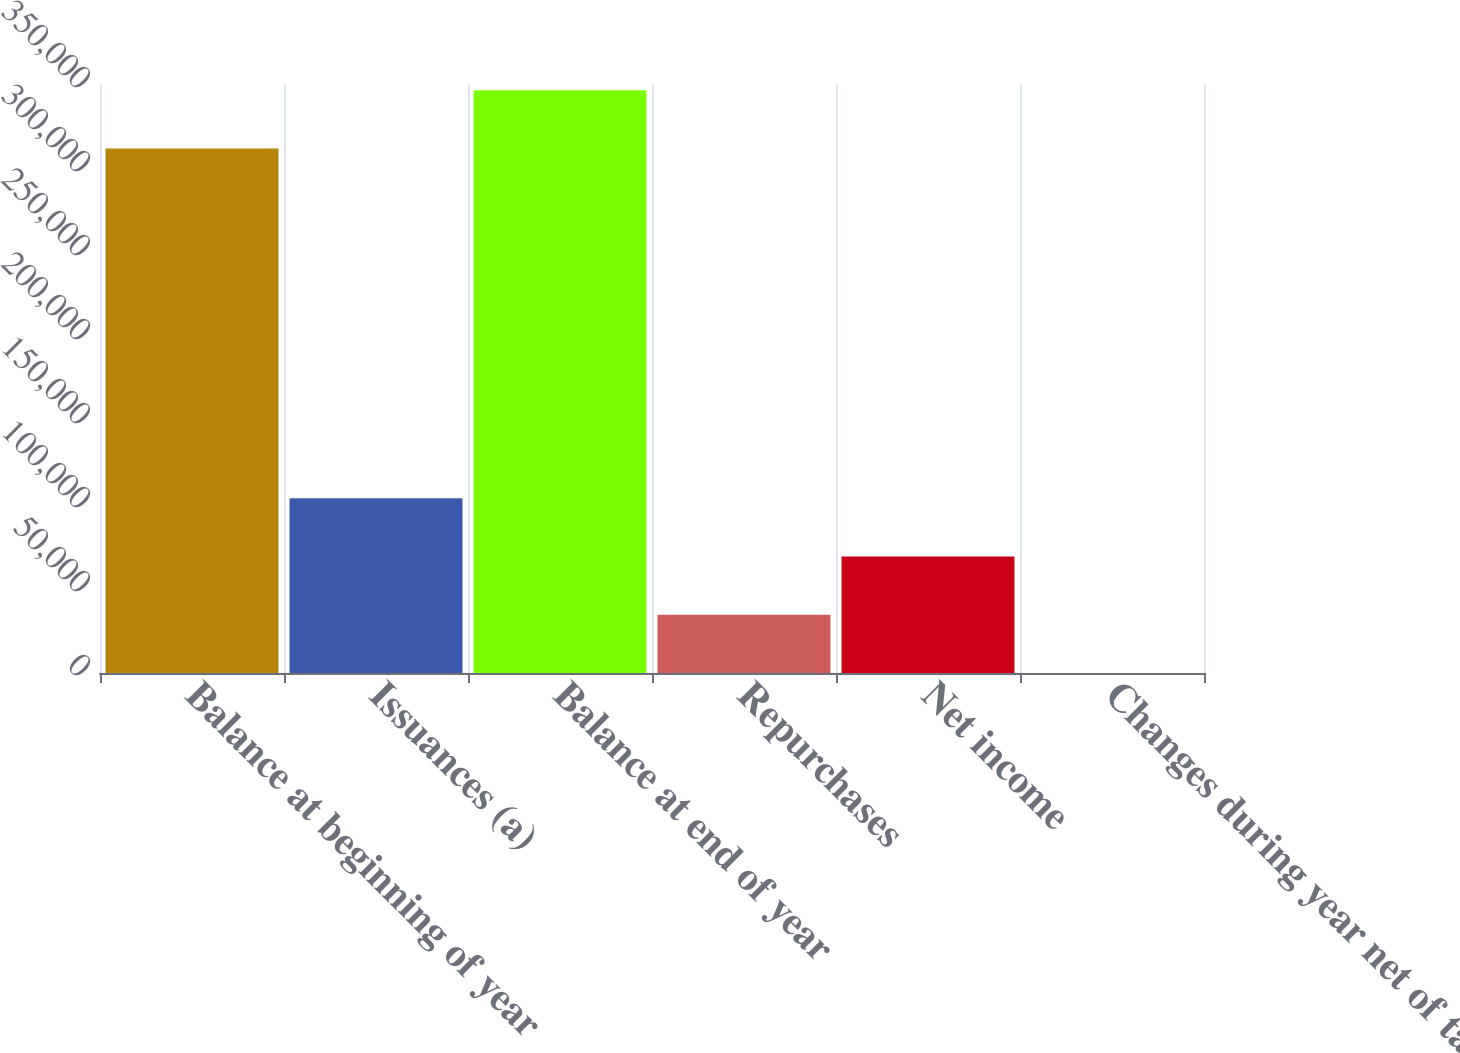Convert chart to OTSL. <chart><loc_0><loc_0><loc_500><loc_500><bar_chart><fcel>Balance at beginning of year<fcel>Issuances (a)<fcel>Balance at end of year<fcel>Repurchases<fcel>Net income<fcel>Changes during year net of tax<nl><fcel>312166<fcel>104031<fcel>346836<fcel>34691.6<fcel>69361.2<fcel>22<nl></chart> 